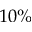<formula> <loc_0><loc_0><loc_500><loc_500>1 0 \%</formula> 